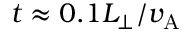<formula> <loc_0><loc_0><loc_500><loc_500>t \approx 0 . 1 L _ { \perp } / v _ { A }</formula> 